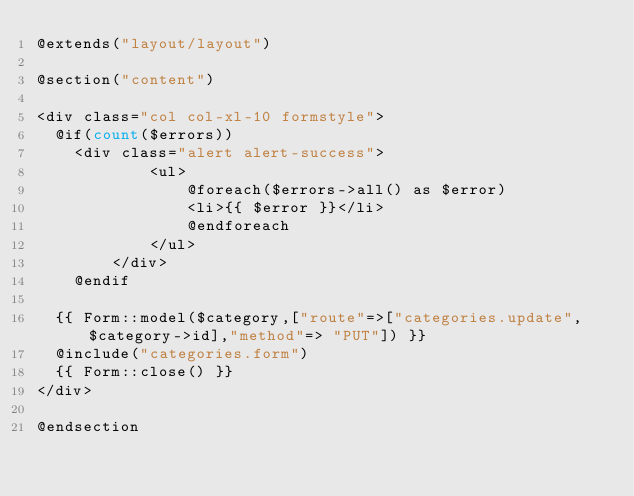Convert code to text. <code><loc_0><loc_0><loc_500><loc_500><_PHP_>@extends("layout/layout")

@section("content")

<div class="col col-xl-10 formstyle">
	@if(count($errors))
		<div class="alert alert-success">
            <ul>
                @foreach($errors->all() as $error)
                <li>{{ $error }}</li>                                        
                @endforeach
            </ul>
        </div>
    @endif

	{{ Form::model($category,["route"=>["categories.update",$category->id],"method"=> "PUT"]) }}
	@include("categories.form")
	{{ Form::close() }}
</div>

@endsection</code> 